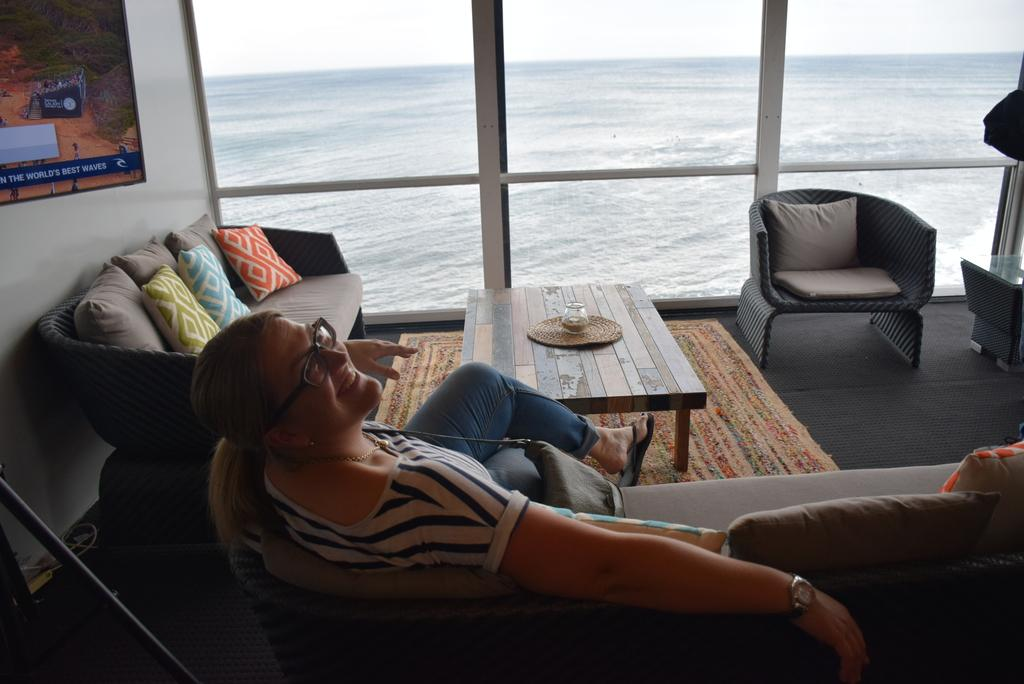What is the lady in the image doing? The lady is sitting on a sofa in the image. How many sofas are visible in the room? There are unoccupied sofas in the room in addition to the one the lady is sitting on. What can be seen through the glass window in the background? The sea is visible through the glass window. What type of produce is being dropped from the ceiling in the image? There is no produce or any indication of something being dropped from the ceiling in the image. 